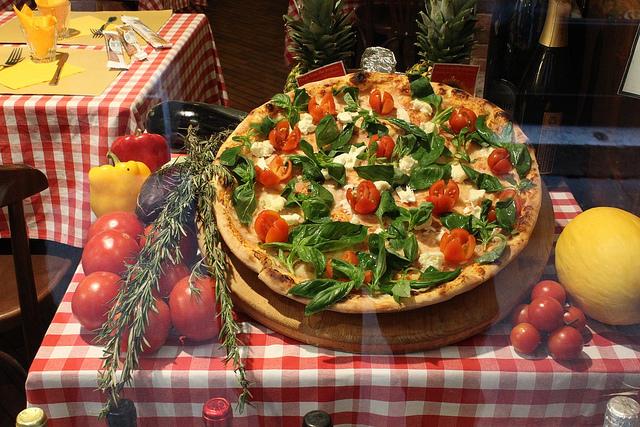What is the name for this specific pizza recipe?
Short answer required. Margarita. Which side of the table are the small tomatoes on?
Give a very brief answer. Right. Can Pineapple pizza be made?
Quick response, please. Yes. 